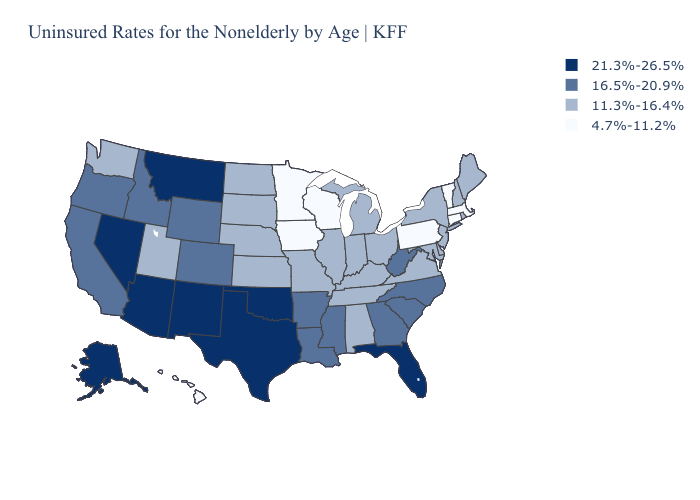Which states hav the highest value in the Northeast?
Be succinct. Maine, New Hampshire, New Jersey, New York, Rhode Island. Among the states that border Kentucky , which have the highest value?
Keep it brief. West Virginia. What is the highest value in the USA?
Concise answer only. 21.3%-26.5%. Does Wisconsin have a higher value than Kansas?
Short answer required. No. What is the lowest value in the USA?
Quick response, please. 4.7%-11.2%. What is the value of New Mexico?
Concise answer only. 21.3%-26.5%. What is the value of Maryland?
Keep it brief. 11.3%-16.4%. Name the states that have a value in the range 4.7%-11.2%?
Give a very brief answer. Connecticut, Hawaii, Iowa, Massachusetts, Minnesota, Pennsylvania, Vermont, Wisconsin. Name the states that have a value in the range 11.3%-16.4%?
Keep it brief. Alabama, Delaware, Illinois, Indiana, Kansas, Kentucky, Maine, Maryland, Michigan, Missouri, Nebraska, New Hampshire, New Jersey, New York, North Dakota, Ohio, Rhode Island, South Dakota, Tennessee, Utah, Virginia, Washington. What is the lowest value in the Northeast?
Short answer required. 4.7%-11.2%. Name the states that have a value in the range 11.3%-16.4%?
Give a very brief answer. Alabama, Delaware, Illinois, Indiana, Kansas, Kentucky, Maine, Maryland, Michigan, Missouri, Nebraska, New Hampshire, New Jersey, New York, North Dakota, Ohio, Rhode Island, South Dakota, Tennessee, Utah, Virginia, Washington. Does Mississippi have the highest value in the South?
Keep it brief. No. Does the map have missing data?
Quick response, please. No. Which states hav the highest value in the Northeast?
Give a very brief answer. Maine, New Hampshire, New Jersey, New York, Rhode Island. Does Rhode Island have the lowest value in the Northeast?
Give a very brief answer. No. 